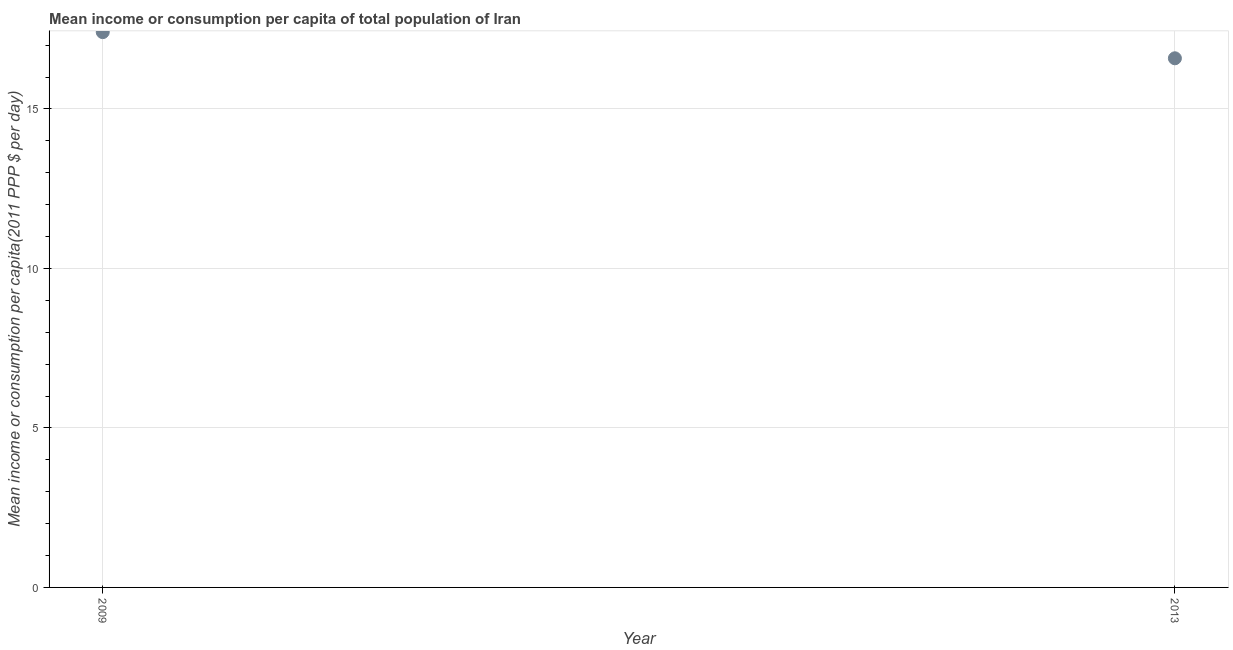What is the mean income or consumption in 2009?
Keep it short and to the point. 17.41. Across all years, what is the maximum mean income or consumption?
Provide a short and direct response. 17.41. Across all years, what is the minimum mean income or consumption?
Make the answer very short. 16.59. What is the difference between the mean income or consumption in 2009 and 2013?
Your answer should be very brief. 0.82. Do a majority of the years between 2013 and 2009 (inclusive) have mean income or consumption greater than 7 $?
Your response must be concise. No. What is the ratio of the mean income or consumption in 2009 to that in 2013?
Your response must be concise. 1.05. In how many years, is the mean income or consumption greater than the average mean income or consumption taken over all years?
Keep it short and to the point. 1. How many years are there in the graph?
Your response must be concise. 2. Are the values on the major ticks of Y-axis written in scientific E-notation?
Offer a terse response. No. Does the graph contain grids?
Your answer should be very brief. Yes. What is the title of the graph?
Provide a succinct answer. Mean income or consumption per capita of total population of Iran. What is the label or title of the Y-axis?
Give a very brief answer. Mean income or consumption per capita(2011 PPP $ per day). What is the Mean income or consumption per capita(2011 PPP $ per day) in 2009?
Your answer should be very brief. 17.41. What is the Mean income or consumption per capita(2011 PPP $ per day) in 2013?
Provide a succinct answer. 16.59. What is the difference between the Mean income or consumption per capita(2011 PPP $ per day) in 2009 and 2013?
Offer a terse response. 0.82. What is the ratio of the Mean income or consumption per capita(2011 PPP $ per day) in 2009 to that in 2013?
Your answer should be compact. 1.05. 